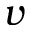<formula> <loc_0><loc_0><loc_500><loc_500>v</formula> 